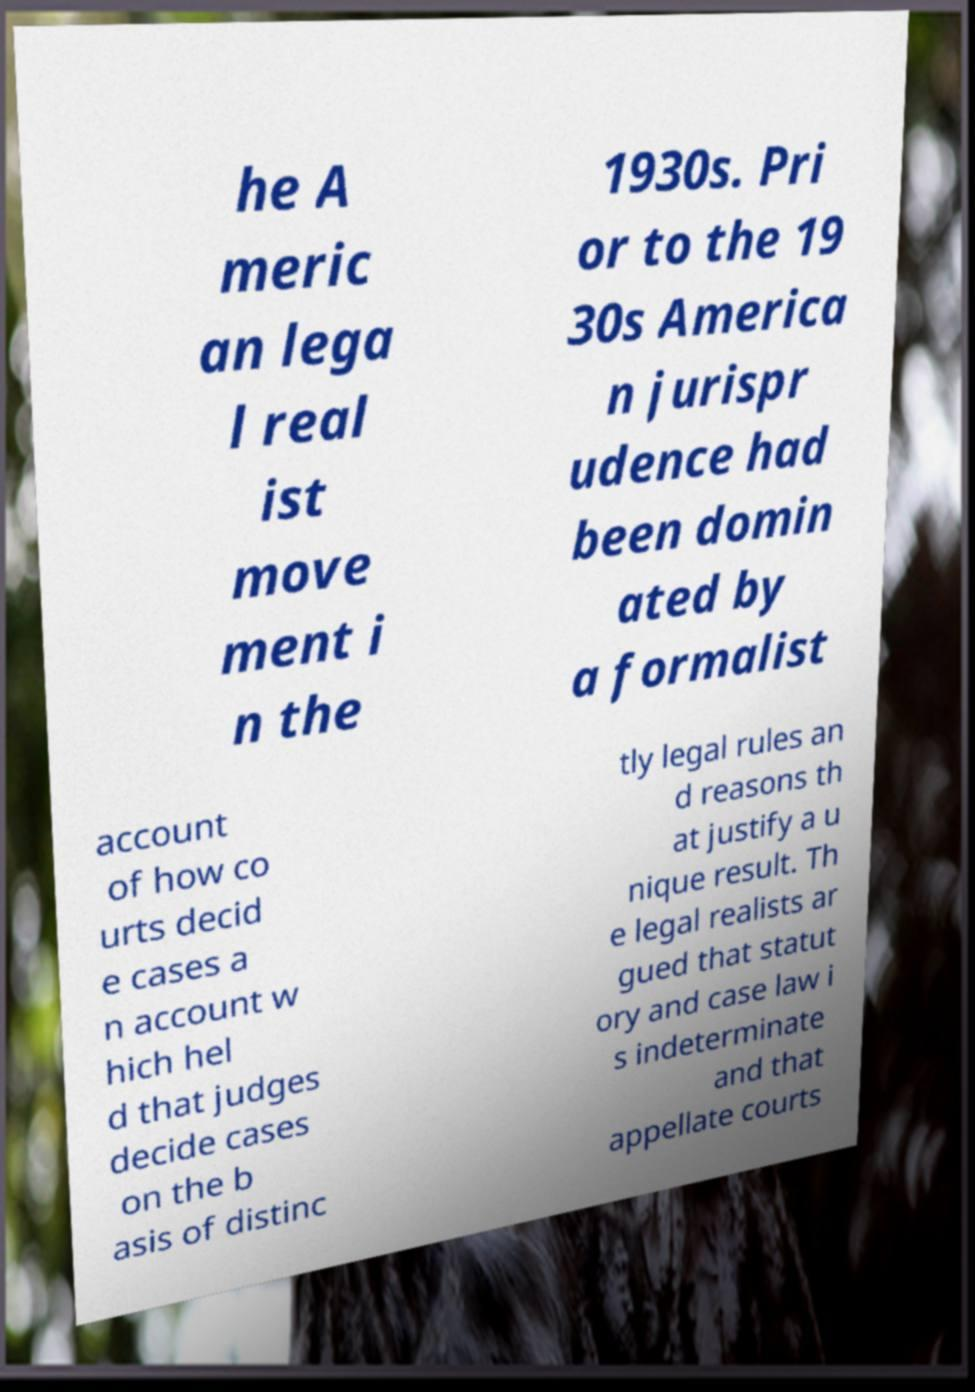I need the written content from this picture converted into text. Can you do that? he A meric an lega l real ist move ment i n the 1930s. Pri or to the 19 30s America n jurispr udence had been domin ated by a formalist account of how co urts decid e cases a n account w hich hel d that judges decide cases on the b asis of distinc tly legal rules an d reasons th at justify a u nique result. Th e legal realists ar gued that statut ory and case law i s indeterminate and that appellate courts 